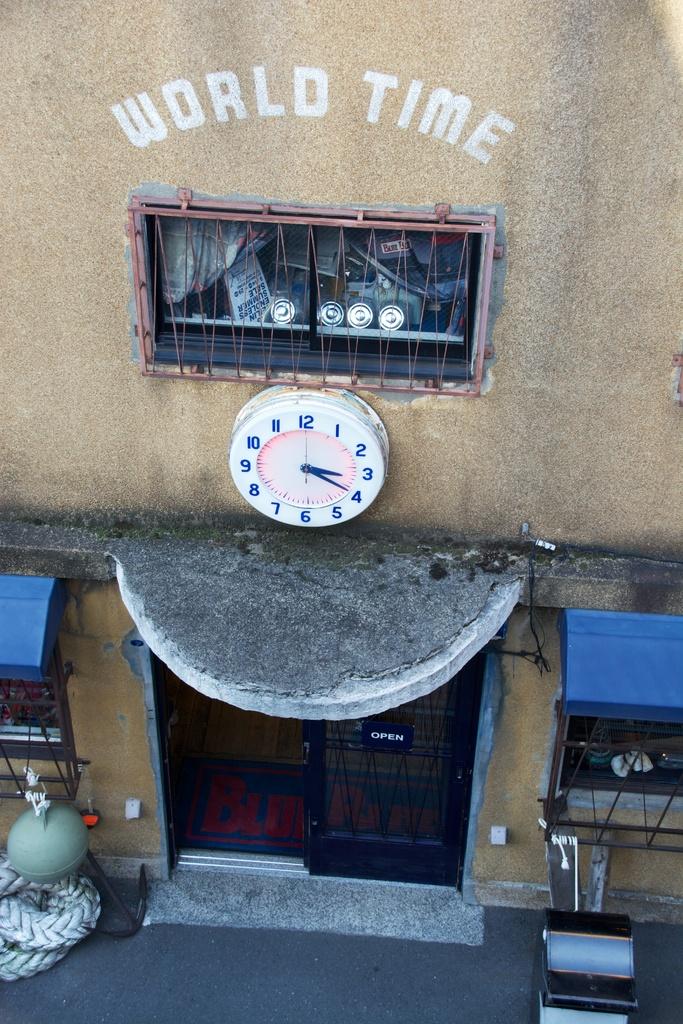What two words are written on the building?
Your response must be concise. World time. 